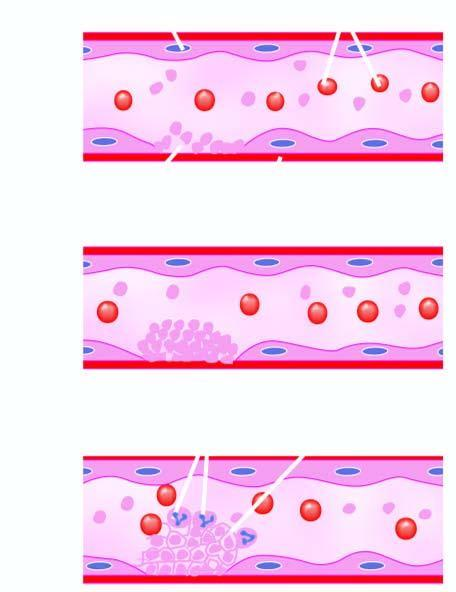what exposes subendothelium, initiating adherence of platelets and activation of coagulation system?
Answer the question using a single word or phrase. Endothelial injury 